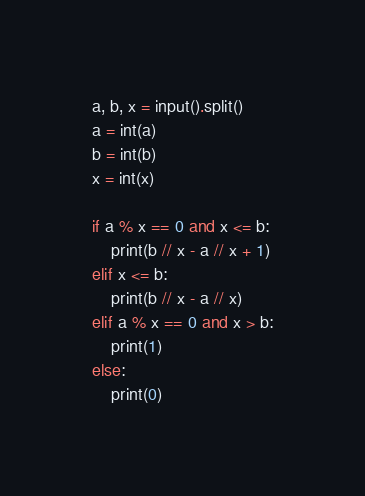Convert code to text. <code><loc_0><loc_0><loc_500><loc_500><_Python_>a, b, x = input().split()
a = int(a)
b = int(b)
x = int(x)

if a % x == 0 and x <= b:
    print(b // x - a // x + 1)
elif x <= b:
    print(b // x - a // x)
elif a % x == 0 and x > b:
    print(1)
else:
    print(0)</code> 